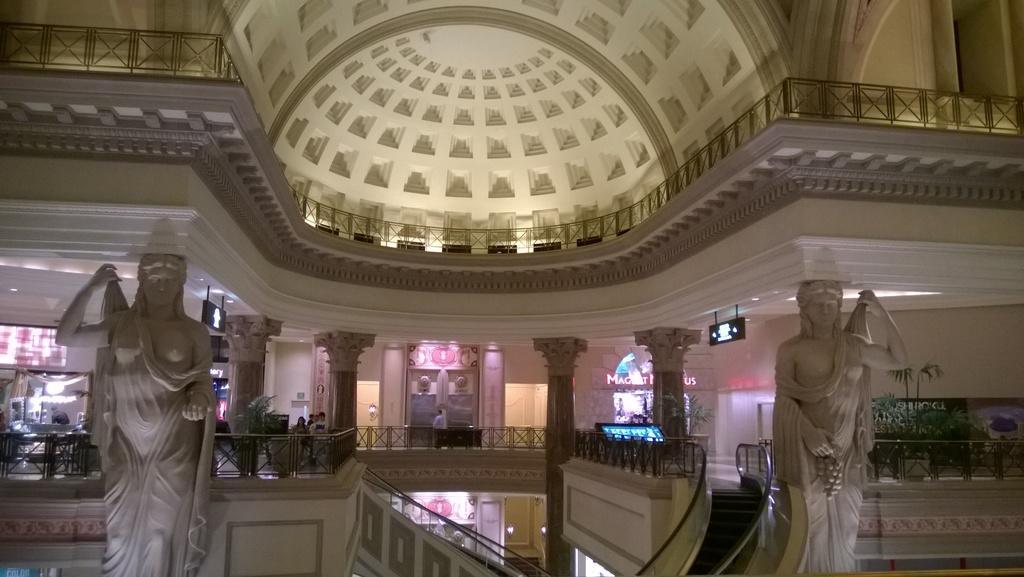Please provide a concise description of this image. In this image I can see few sculptures which are in white colour. In background I can see few pillars, stairs and few boards. 